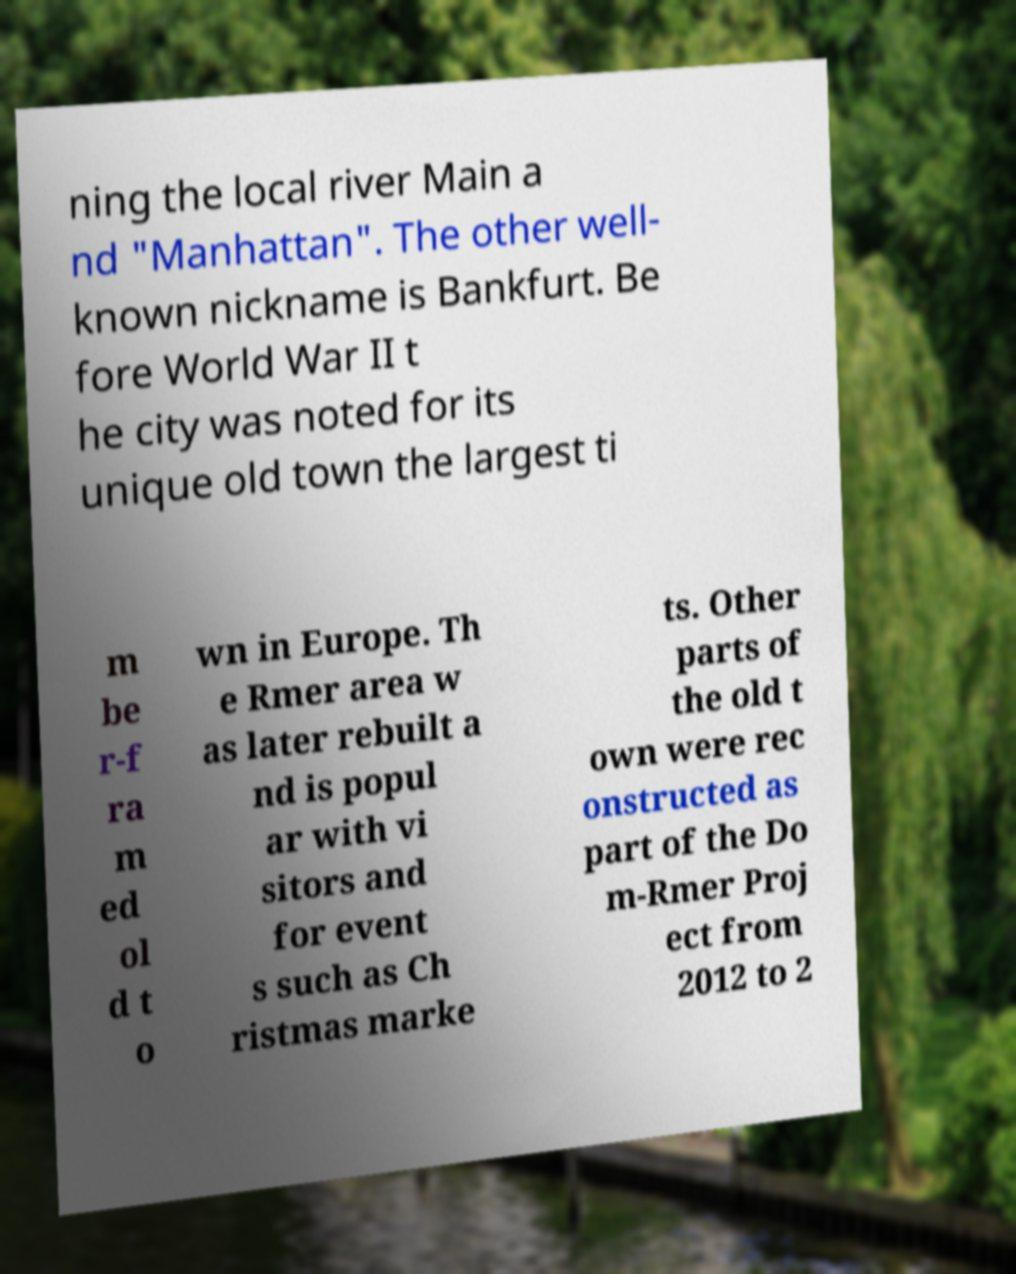Can you read and provide the text displayed in the image?This photo seems to have some interesting text. Can you extract and type it out for me? ning the local river Main a nd "Manhattan". The other well- known nickname is Bankfurt. Be fore World War II t he city was noted for its unique old town the largest ti m be r-f ra m ed ol d t o wn in Europe. Th e Rmer area w as later rebuilt a nd is popul ar with vi sitors and for event s such as Ch ristmas marke ts. Other parts of the old t own were rec onstructed as part of the Do m-Rmer Proj ect from 2012 to 2 